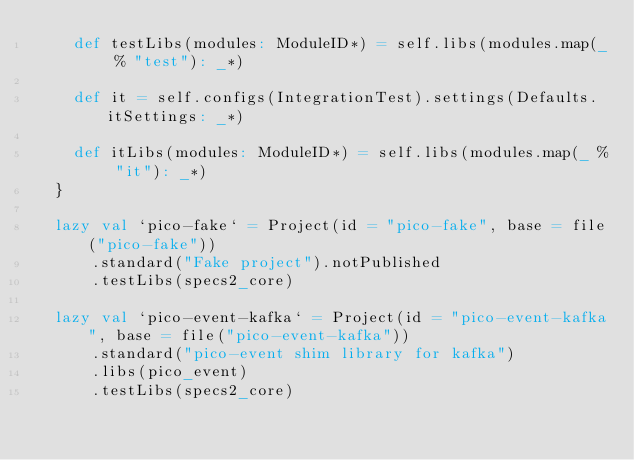<code> <loc_0><loc_0><loc_500><loc_500><_Scala_>    def testLibs(modules: ModuleID*) = self.libs(modules.map(_ % "test"): _*)

    def it = self.configs(IntegrationTest).settings(Defaults.itSettings: _*)

    def itLibs(modules: ModuleID*) = self.libs(modules.map(_ % "it"): _*)
  }

  lazy val `pico-fake` = Project(id = "pico-fake", base = file("pico-fake"))
      .standard("Fake project").notPublished
      .testLibs(specs2_core)

  lazy val `pico-event-kafka` = Project(id = "pico-event-kafka", base = file("pico-event-kafka"))
      .standard("pico-event shim library for kafka")
      .libs(pico_event)
      .testLibs(specs2_core)
</code> 